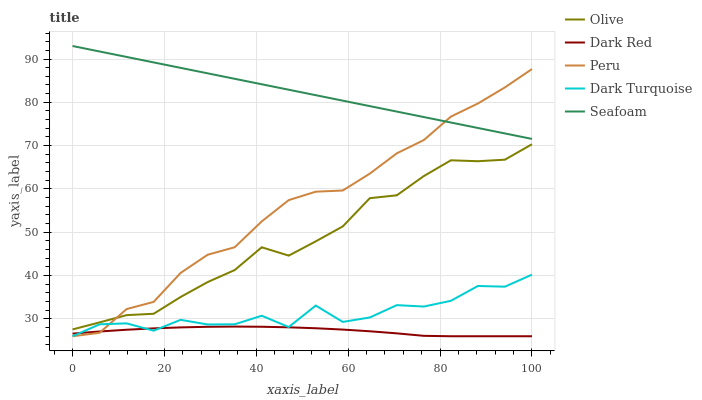Does Dark Red have the minimum area under the curve?
Answer yes or no. Yes. Does Seafoam have the maximum area under the curve?
Answer yes or no. Yes. Does Seafoam have the minimum area under the curve?
Answer yes or no. No. Does Dark Red have the maximum area under the curve?
Answer yes or no. No. Is Seafoam the smoothest?
Answer yes or no. Yes. Is Dark Turquoise the roughest?
Answer yes or no. Yes. Is Dark Red the smoothest?
Answer yes or no. No. Is Dark Red the roughest?
Answer yes or no. No. Does Dark Red have the lowest value?
Answer yes or no. Yes. Does Seafoam have the lowest value?
Answer yes or no. No. Does Seafoam have the highest value?
Answer yes or no. Yes. Does Dark Red have the highest value?
Answer yes or no. No. Is Dark Turquoise less than Seafoam?
Answer yes or no. Yes. Is Seafoam greater than Olive?
Answer yes or no. Yes. Does Dark Turquoise intersect Peru?
Answer yes or no. Yes. Is Dark Turquoise less than Peru?
Answer yes or no. No. Is Dark Turquoise greater than Peru?
Answer yes or no. No. Does Dark Turquoise intersect Seafoam?
Answer yes or no. No. 